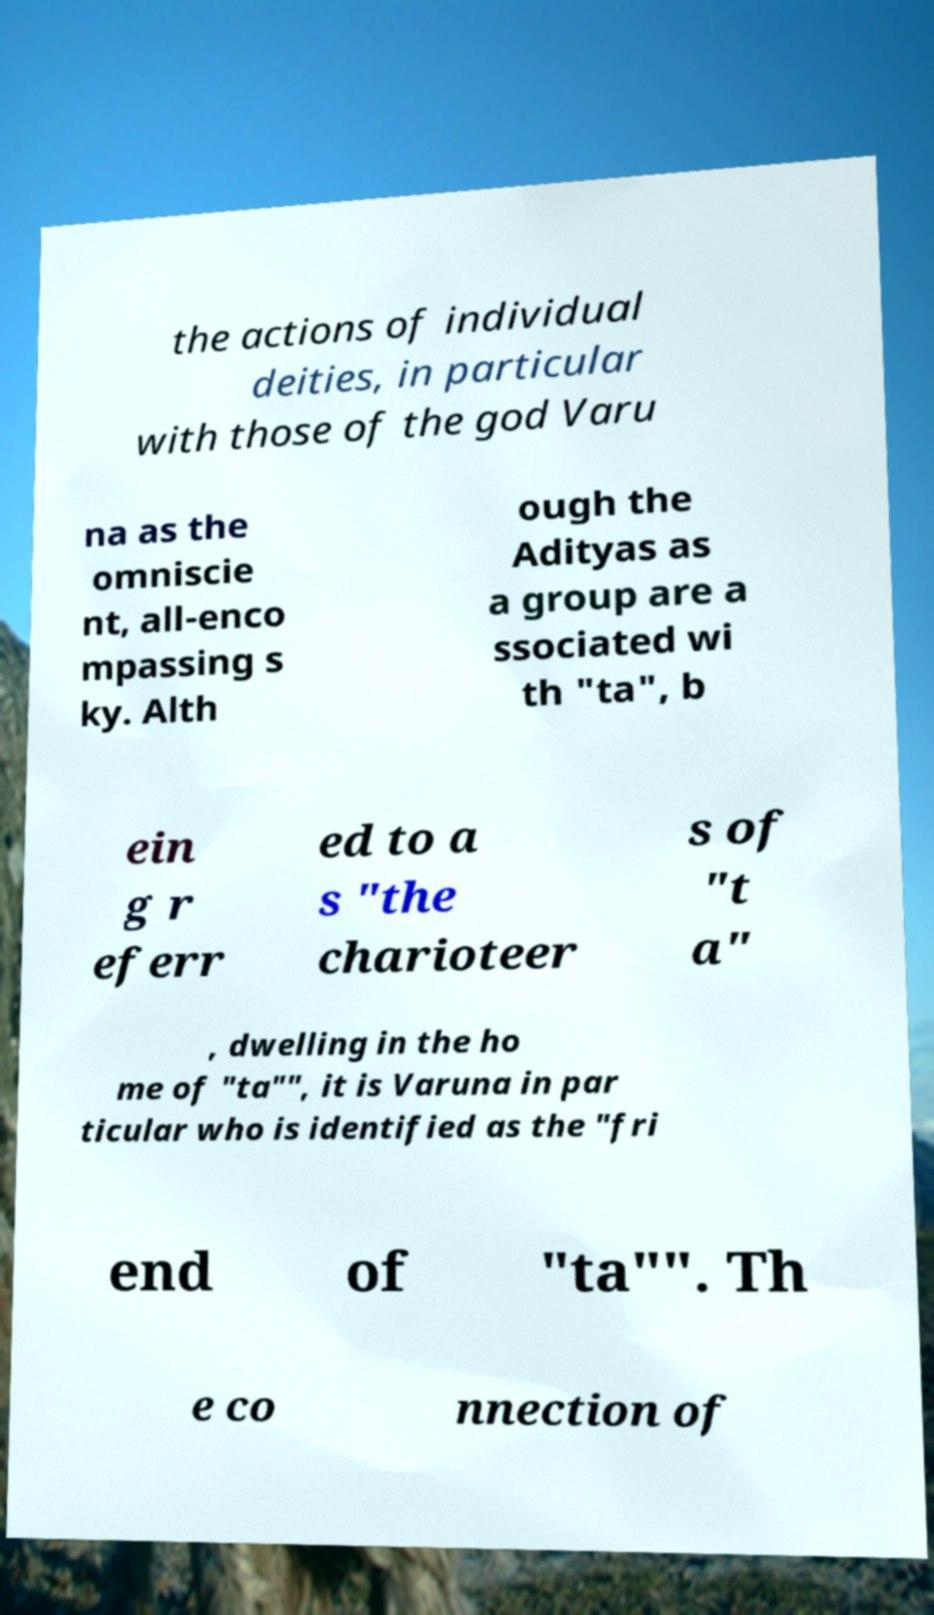Could you assist in decoding the text presented in this image and type it out clearly? the actions of individual deities, in particular with those of the god Varu na as the omniscie nt, all-enco mpassing s ky. Alth ough the Adityas as a group are a ssociated wi th "ta", b ein g r eferr ed to a s "the charioteer s of "t a" , dwelling in the ho me of "ta"", it is Varuna in par ticular who is identified as the "fri end of "ta"". Th e co nnection of 